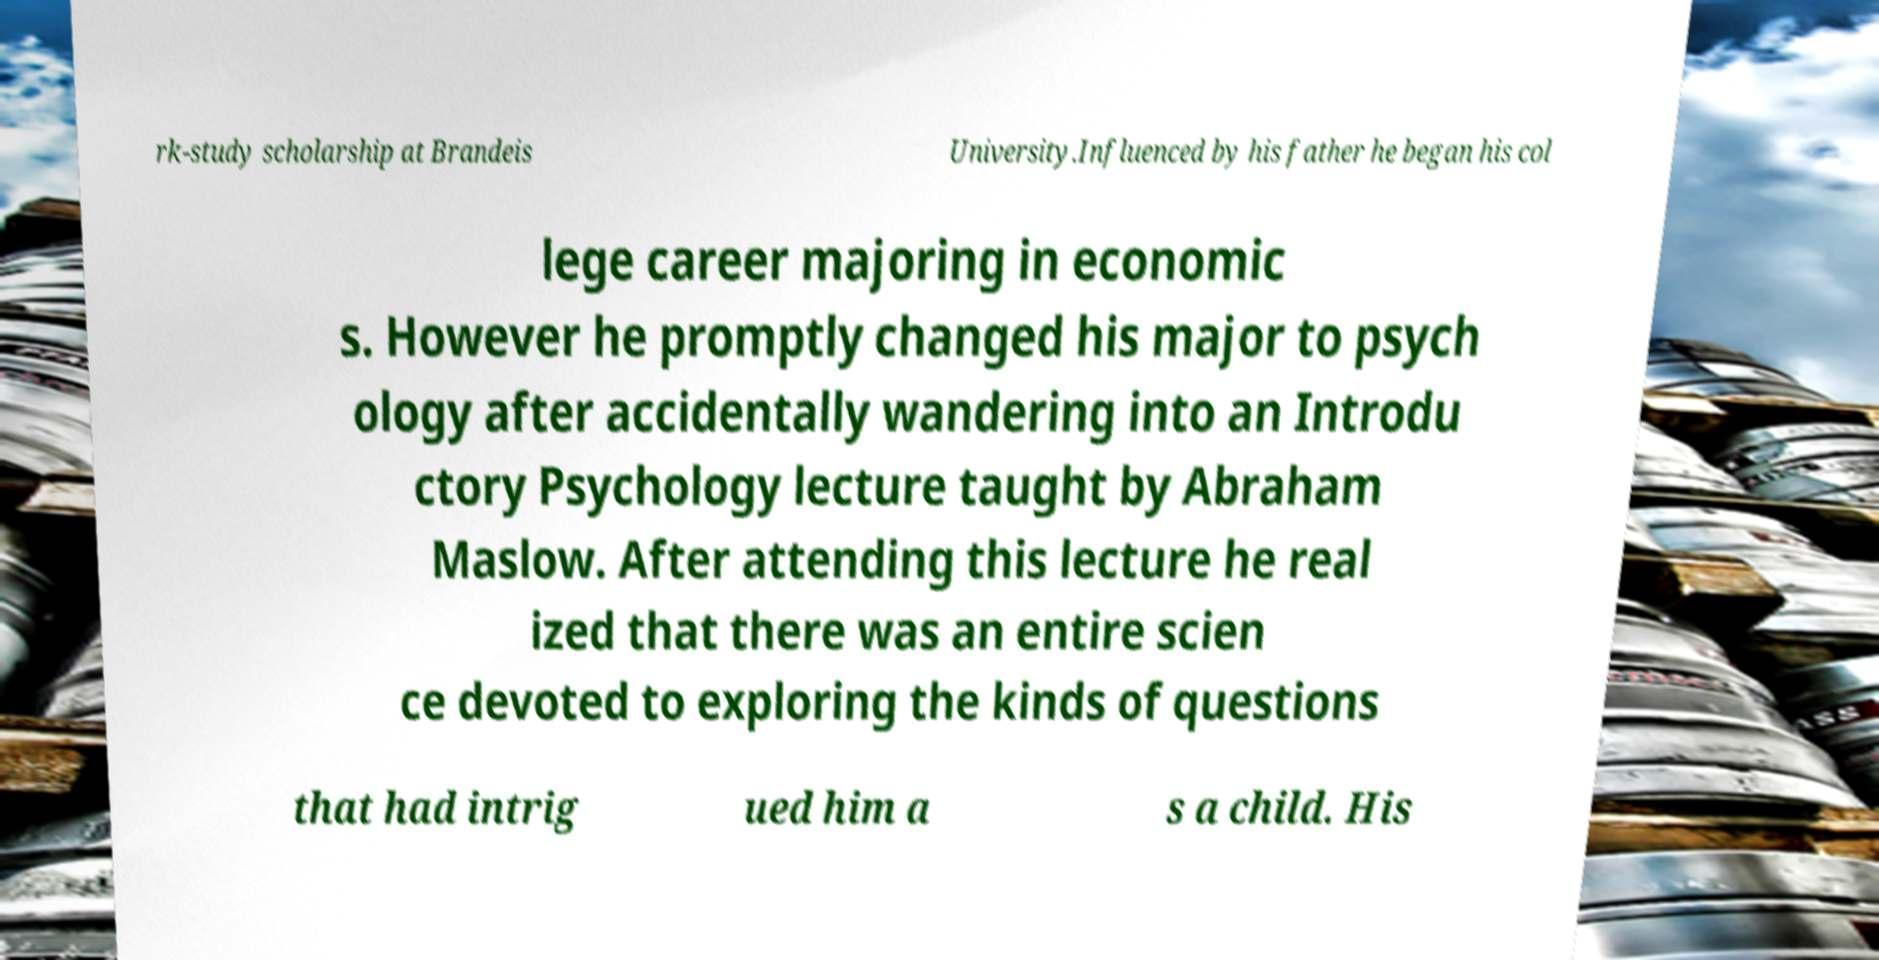What messages or text are displayed in this image? I need them in a readable, typed format. rk-study scholarship at Brandeis University.Influenced by his father he began his col lege career majoring in economic s. However he promptly changed his major to psych ology after accidentally wandering into an Introdu ctory Psychology lecture taught by Abraham Maslow. After attending this lecture he real ized that there was an entire scien ce devoted to exploring the kinds of questions that had intrig ued him a s a child. His 